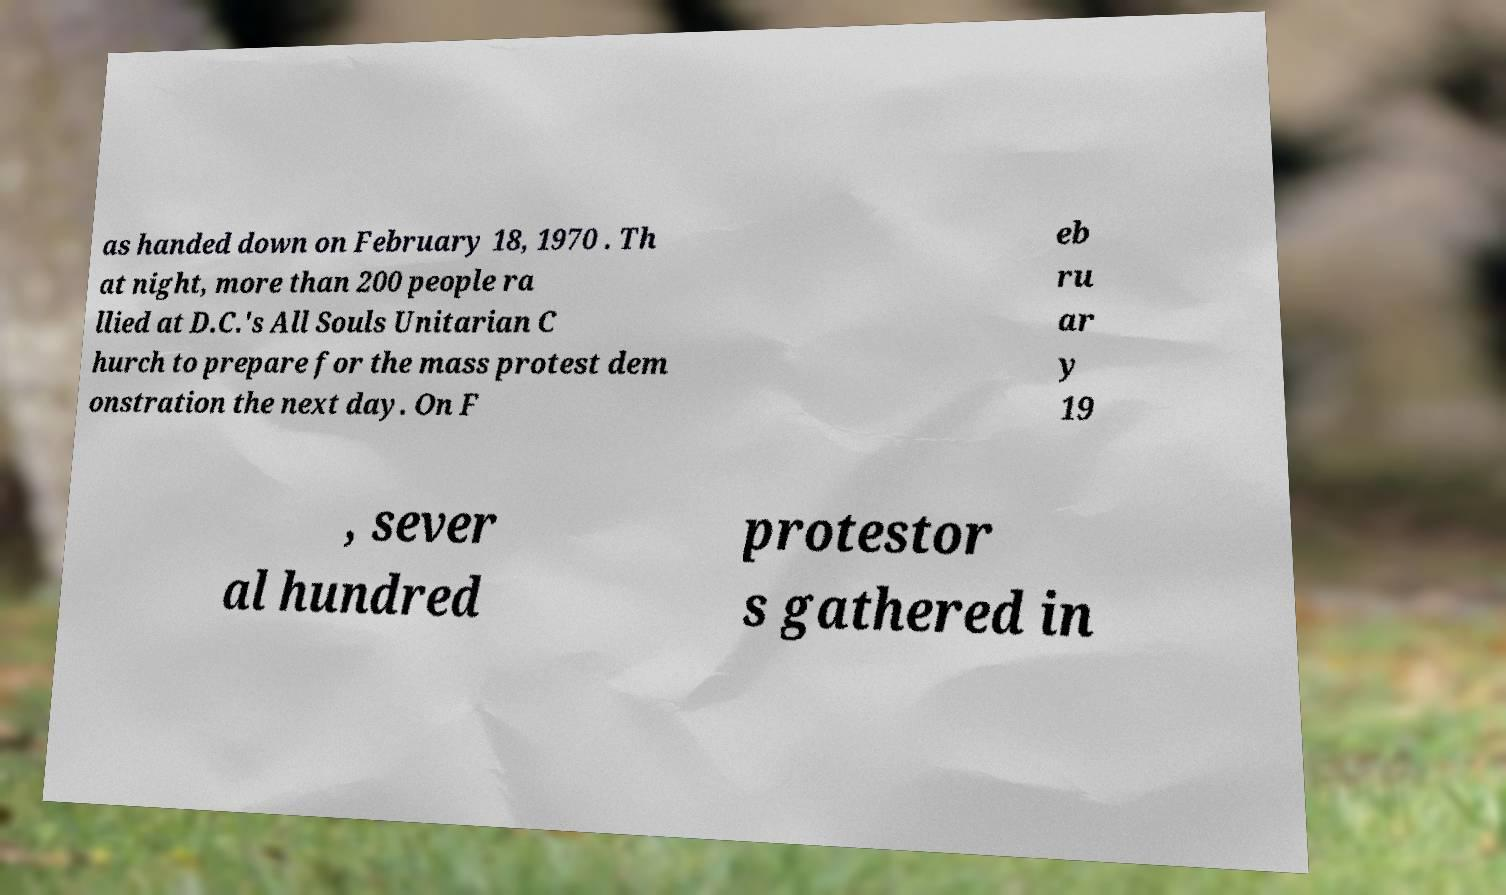I need the written content from this picture converted into text. Can you do that? as handed down on February 18, 1970 . Th at night, more than 200 people ra llied at D.C.'s All Souls Unitarian C hurch to prepare for the mass protest dem onstration the next day. On F eb ru ar y 19 , sever al hundred protestor s gathered in 